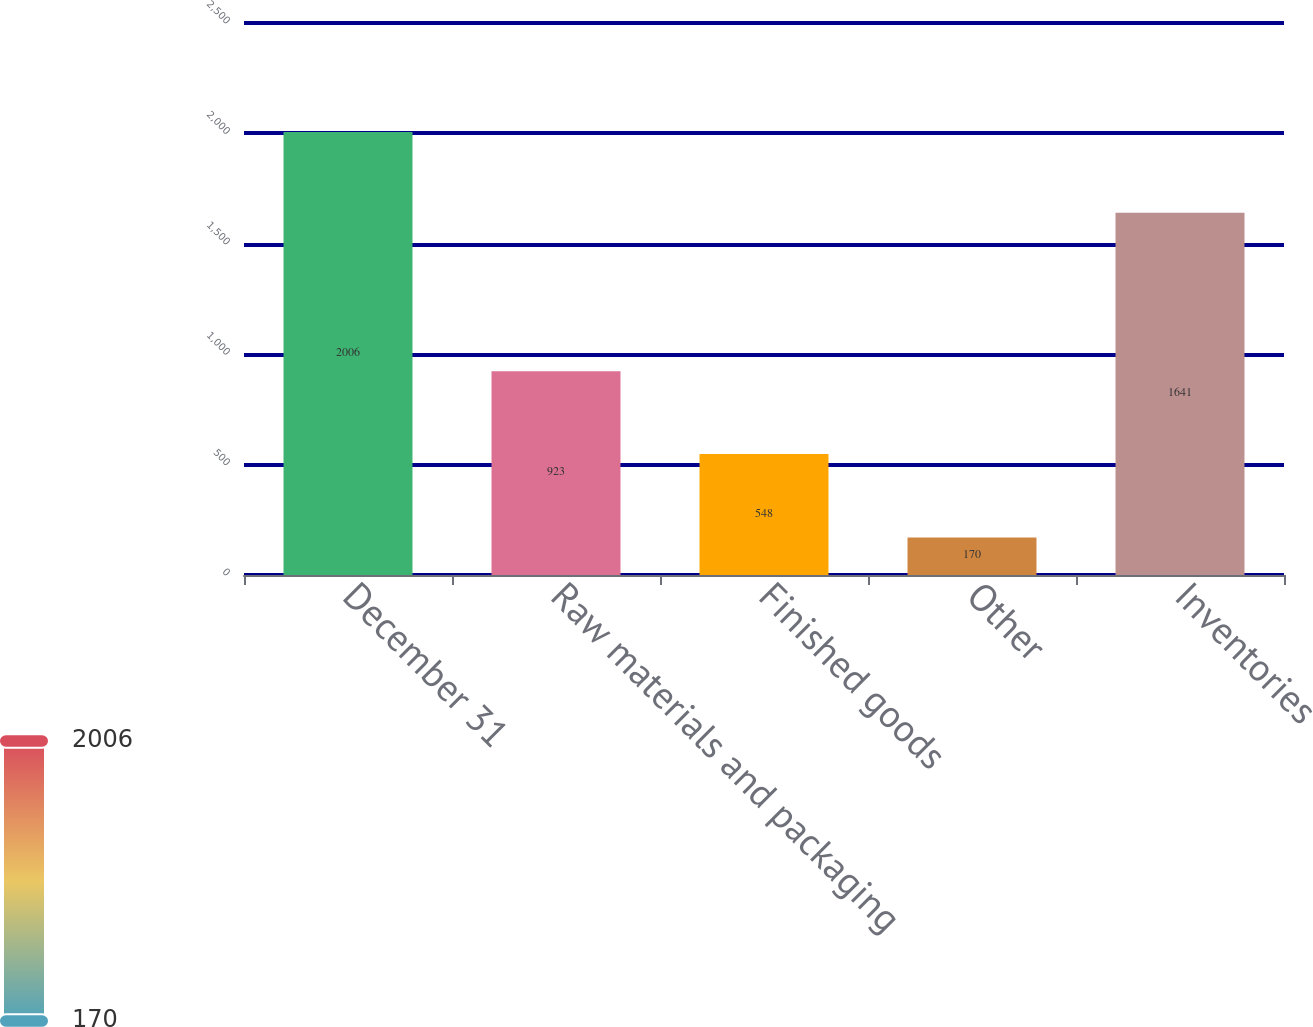<chart> <loc_0><loc_0><loc_500><loc_500><bar_chart><fcel>December 31<fcel>Raw materials and packaging<fcel>Finished goods<fcel>Other<fcel>Inventories<nl><fcel>2006<fcel>923<fcel>548<fcel>170<fcel>1641<nl></chart> 